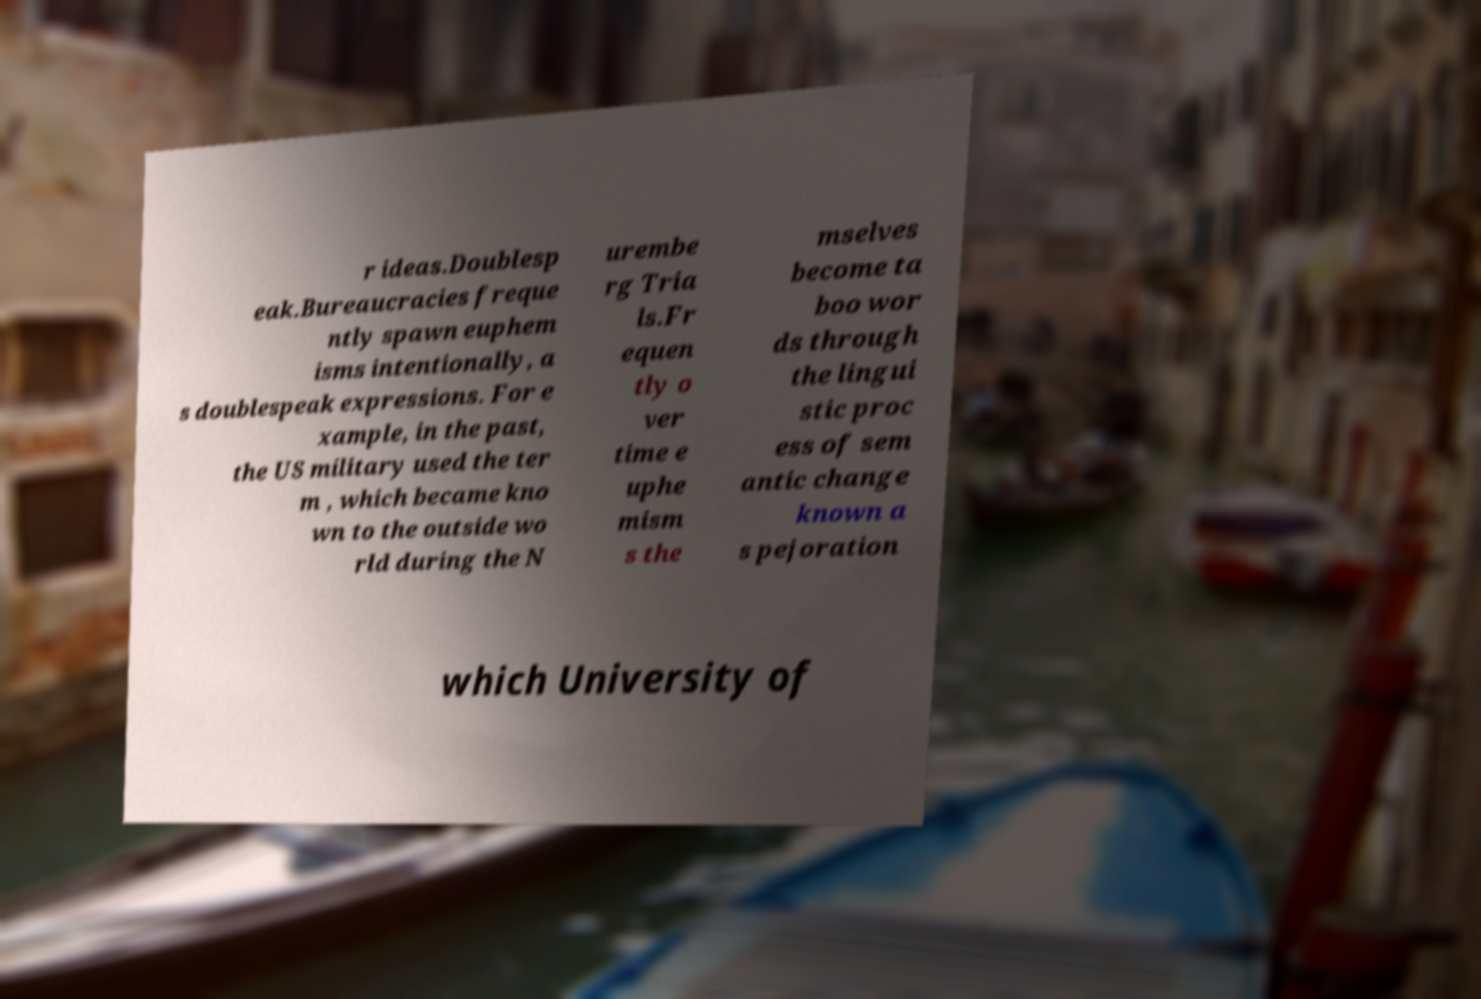What messages or text are displayed in this image? I need them in a readable, typed format. r ideas.Doublesp eak.Bureaucracies freque ntly spawn euphem isms intentionally, a s doublespeak expressions. For e xample, in the past, the US military used the ter m , which became kno wn to the outside wo rld during the N urembe rg Tria ls.Fr equen tly o ver time e uphe mism s the mselves become ta boo wor ds through the lingui stic proc ess of sem antic change known a s pejoration which University of 